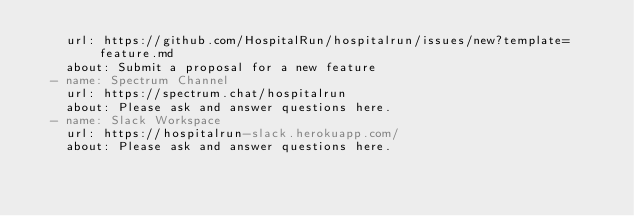<code> <loc_0><loc_0><loc_500><loc_500><_YAML_>    url: https://github.com/HospitalRun/hospitalrun/issues/new?template=feature.md
    about: Submit a proposal for a new feature
  - name: Spectrum Channel
    url: https://spectrum.chat/hospitalrun
    about: Please ask and answer questions here.
  - name: Slack Workspace
    url: https://hospitalrun-slack.herokuapp.com/
    about: Please ask and answer questions here.
</code> 